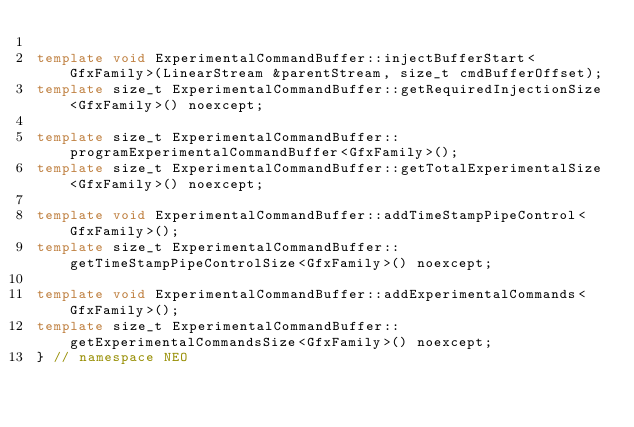<code> <loc_0><loc_0><loc_500><loc_500><_C++_>
template void ExperimentalCommandBuffer::injectBufferStart<GfxFamily>(LinearStream &parentStream, size_t cmdBufferOffset);
template size_t ExperimentalCommandBuffer::getRequiredInjectionSize<GfxFamily>() noexcept;

template size_t ExperimentalCommandBuffer::programExperimentalCommandBuffer<GfxFamily>();
template size_t ExperimentalCommandBuffer::getTotalExperimentalSize<GfxFamily>() noexcept;

template void ExperimentalCommandBuffer::addTimeStampPipeControl<GfxFamily>();
template size_t ExperimentalCommandBuffer::getTimeStampPipeControlSize<GfxFamily>() noexcept;

template void ExperimentalCommandBuffer::addExperimentalCommands<GfxFamily>();
template size_t ExperimentalCommandBuffer::getExperimentalCommandsSize<GfxFamily>() noexcept;
} // namespace NEO
</code> 